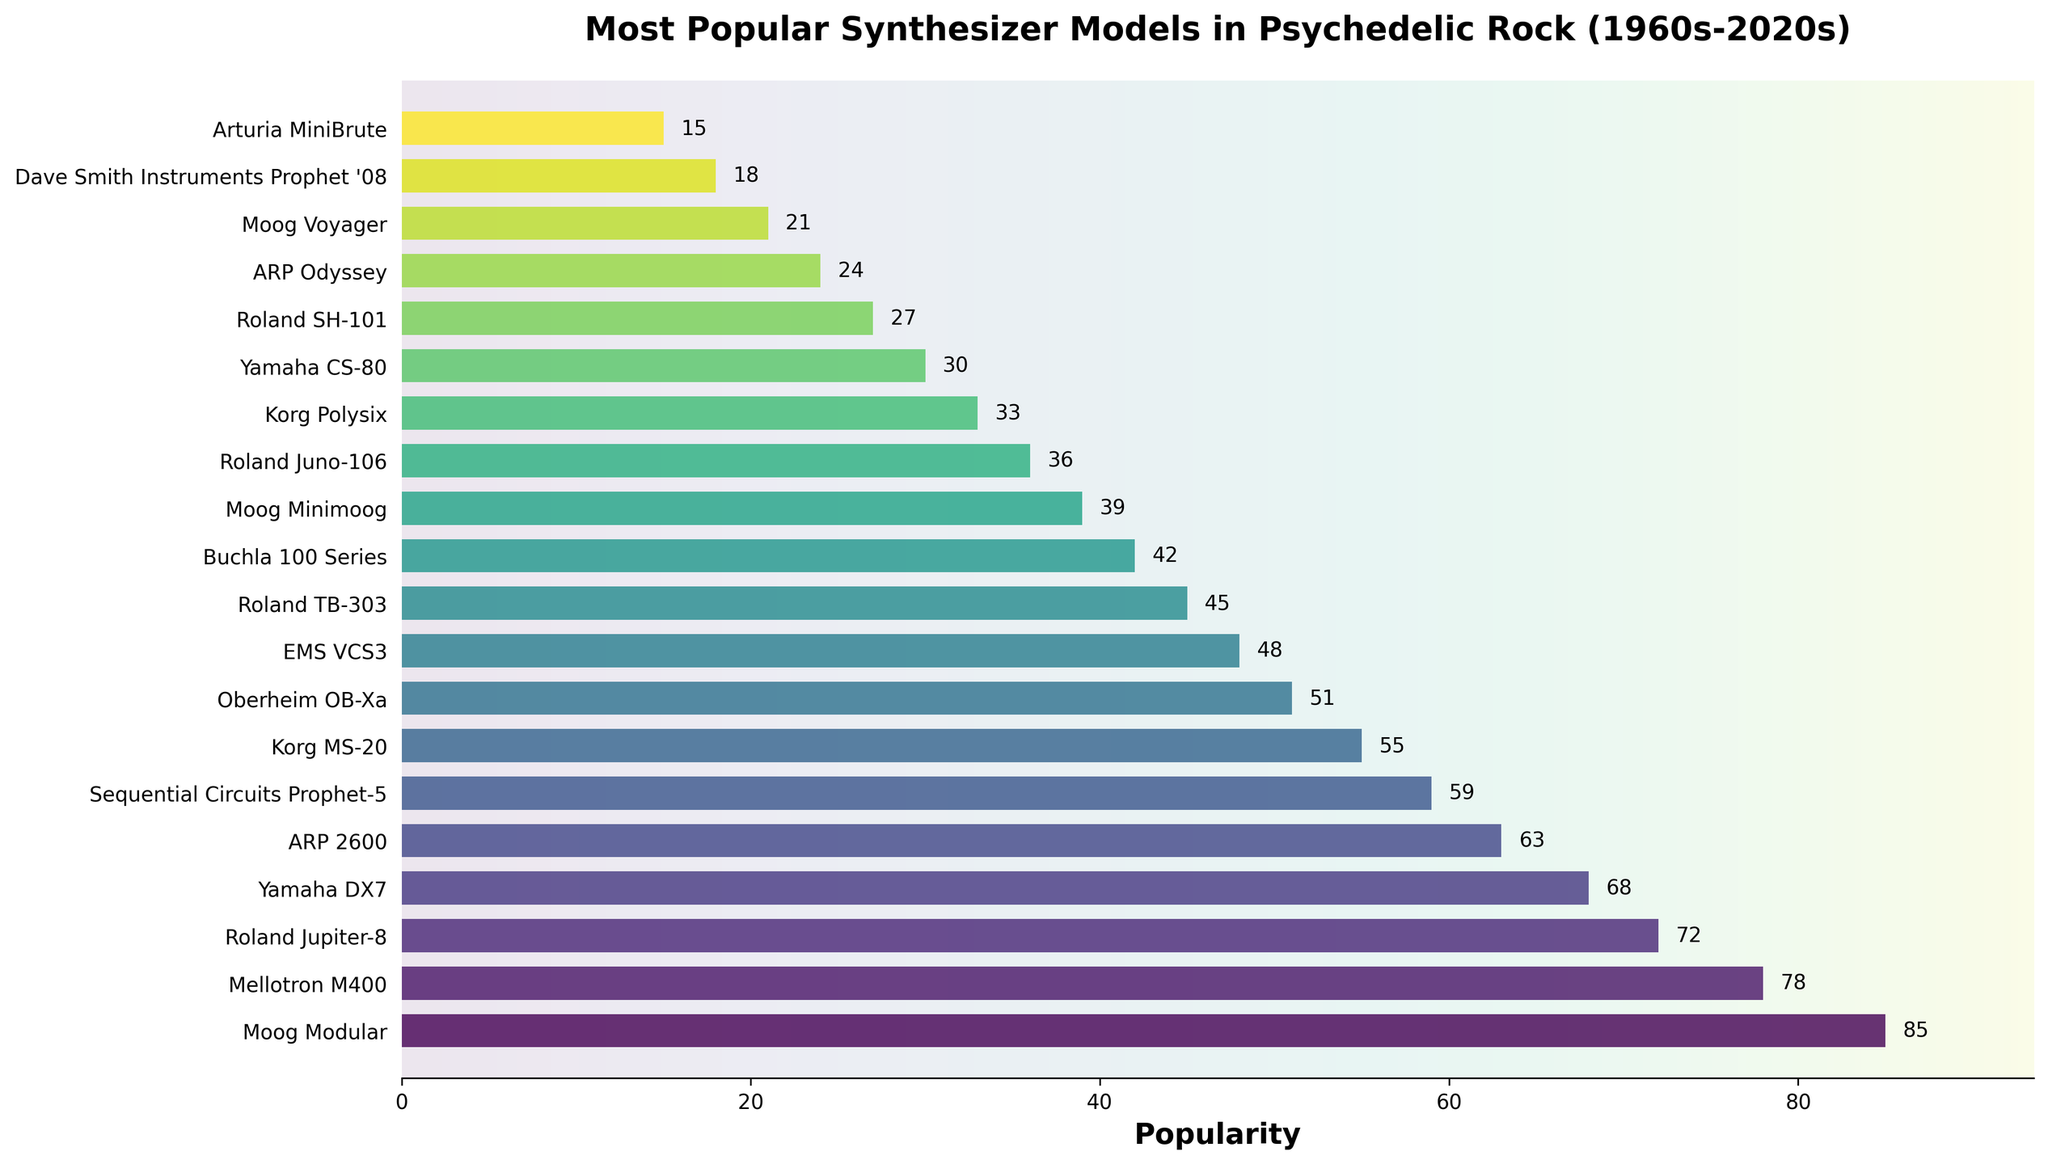What was the most popular synthesizer model in psychedelic rock? The most popular synthesizer model is determined by the highest popularity value on the bar chart, which is the Moog Modular with a popularity of 85.
Answer: Moog Modular Which synthesizer has a higher popularity, the ARP 2600 or the Yamaha DX7? To determine which synthesizer has a higher popularity, compare their popularity values: ARP 2600 has a popularity of 63, while Yamaha DX7 has 68. Therefore, Yamaha DX7 has a higher popularity.
Answer: Yamaha DX7 What is the total popularity of the top three synthesizers combined? The top three synthesizers are Moog Modular (85), Mellotron M400 (78), and Roland Jupiter-8 (72). Adding these values together gives 85 + 78 + 72 = 235.
Answer: 235 How much more popular is the Sequential Circuits Prophet-5 compared to the Korg MS-20? Sequential Circuits Prophet-5 has a popularity of 59, and Korg MS-20 has 55. The difference is 59 - 55 = 4.
Answer: 4 Which two synthesizers have the closest popularity scores? By comparing the popularity scores, the two synthesizers with the closest popularity are the Sequential Circuits Prophet-5 (59) and the Korg MS-20 (55), with a difference of 4.
Answer: Sequential Circuits Prophet-5 and Korg MS-20 Which synthesizer is ranked 10th in terms of popularity? The synthesizer ranked 10th in terms of popularity can be identified as the Roland TB-303, with a popularity of 45.
Answer: Roland TB-303 Among the least popular models (bottom 5), which one is the most popular? The least popular models are Arturia MiniBrute (15), Dave Smith Instruments Prophet '08 (18), Moog Voyager (21), ARP Odyssey (24), and Roland SH-101 (27). Among these, the most popular is the Roland SH-101.
Answer: Roland SH-101 What visual attribute is unique about the bars representing the popularity values? All the bars use a gradient color palette from viridis, and the bars are horizontally oriented, while the exact popularity value is labeled next to each bar.
Answer: Gradient color palette Between the 1960s and 2020s, how many synthesizer models listed have a popularity value of 50 or more? Models with a popularity of 50 or more are Moog Modular (85), Mellotron M400 (78), Roland Jupiter-8 (72), Yamaha DX7 (68), ARP 2600 (63), and Sequential Circuits Prophet-5 (59), making a total of 6 synthesizer models.
Answer: 6 